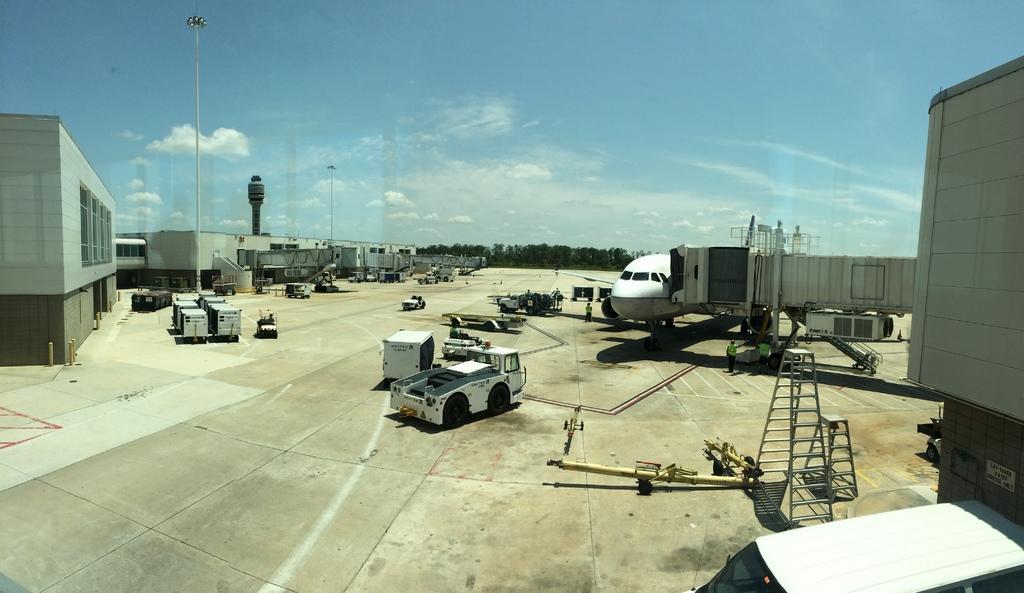Can you describe this image briefly? In this image, I can see an airplane, ladders, ground support equipments, vehicles, three persons standing and a passenger walkway on the runway. On the left side of the image, I can see the buildings and an air traffic control tower. In the background, there are trees and the sky. 